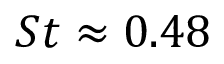<formula> <loc_0><loc_0><loc_500><loc_500>S t \approx 0 . 4 8</formula> 